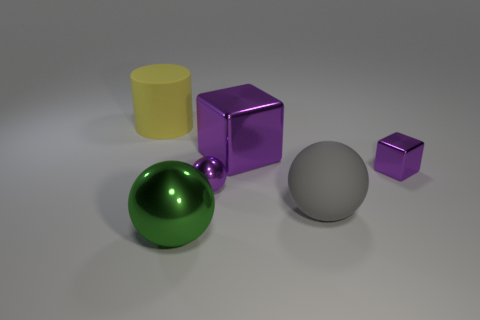Is there a large gray rubber thing that has the same shape as the large yellow thing? After examining the image, it appears that no gray object shares the exact shape with the large yellow cylinder. The image showcases a variety of geometric shapes including a cylinder, cubes, and spheres, each in different colors and sizes. 